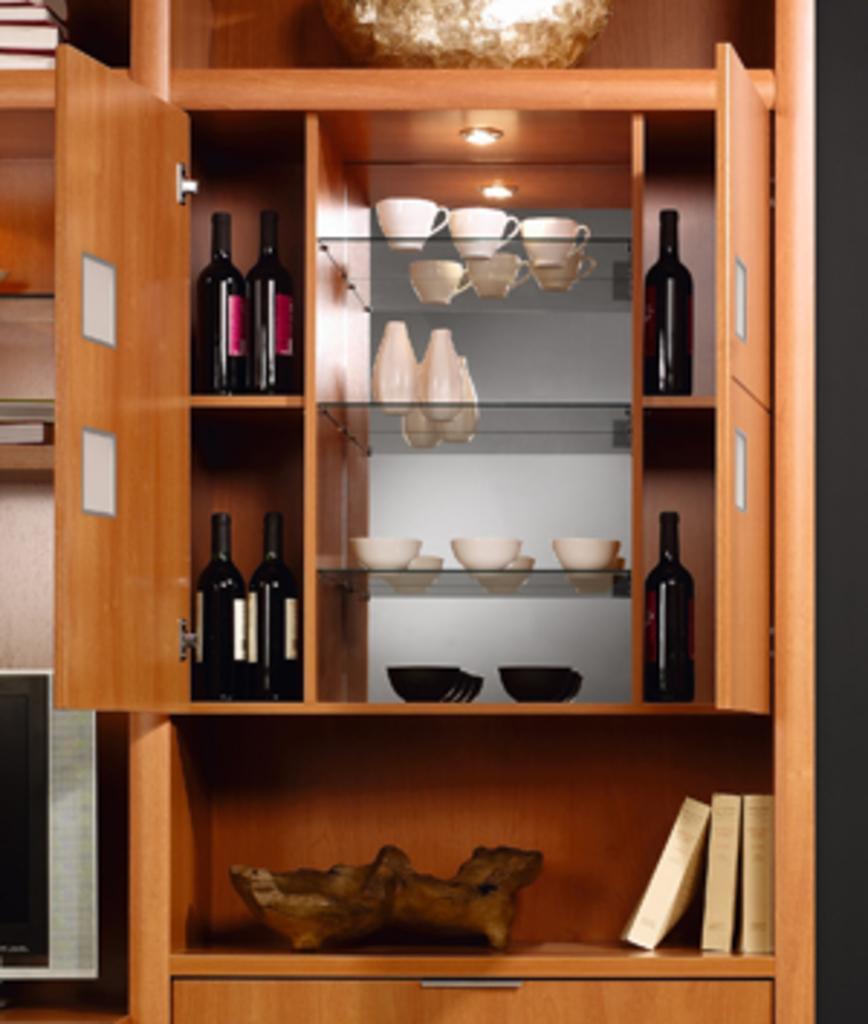Could you give a brief overview of what you see in this image? In this image I can see cupboard and on these shelves I can see white colour cups, black colour bottles, white colour bowls and few black colour bowls. Here I can see few white colour things. 